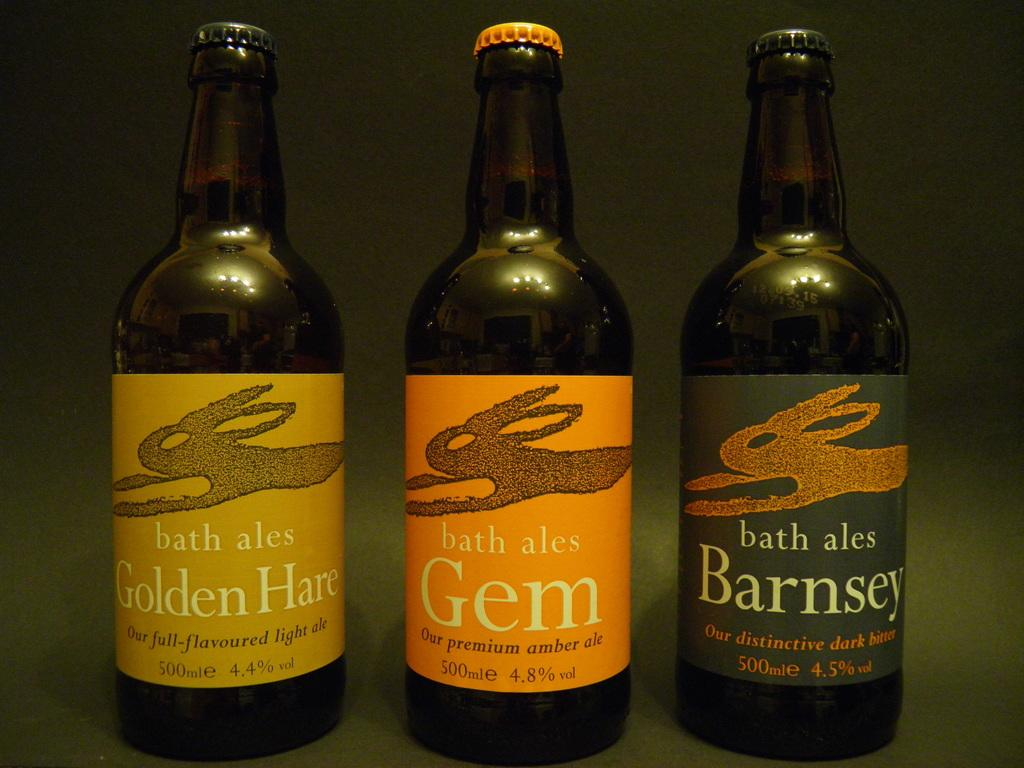<image>
Provide a brief description of the given image. Several variations of bath ales are lined up in a row. 